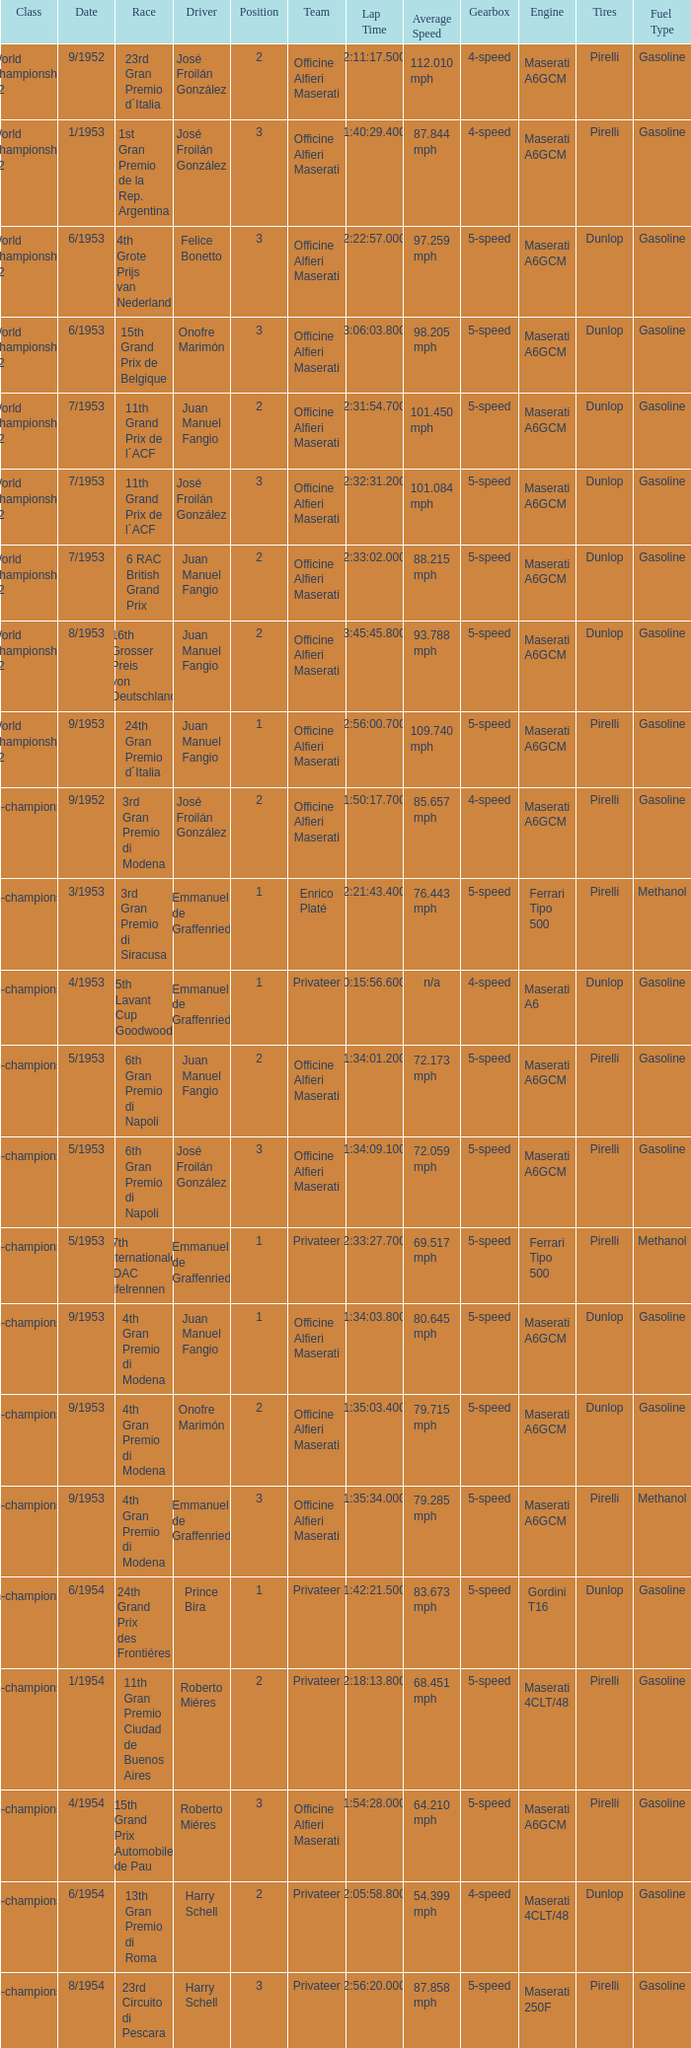Could you help me parse every detail presented in this table? {'header': ['Class', 'Date', 'Race', 'Driver', 'Position', 'Team', 'Lap Time', 'Average Speed', 'Gearbox', 'Engine', 'Tires', 'Fuel Type'], 'rows': [['World Championship F2', '9/1952', '23rd Gran Premio d´Italia', 'José Froilán González', '2', 'Officine Alfieri Maserati', '2:11:17.500', '112.010 mph', '4-speed', 'Maserati A6GCM', 'Pirelli', 'Gasoline'], ['World Championship F2', '1/1953', '1st Gran Premio de la Rep. Argentina', 'José Froilán González', '3', 'Officine Alfieri Maserati', '1:40:29.400', '87.844 mph', '4-speed', 'Maserati A6GCM', 'Pirelli', 'Gasoline'], ['World Championship F2', '6/1953', '4th Grote Prijs van Nederland', 'Felice Bonetto', '3', 'Officine Alfieri Maserati', '2:22:57.000', '97.259 mph', '5-speed', 'Maserati A6GCM', 'Dunlop', 'Gasoline'], ['World Championship F2', '6/1953', '15th Grand Prix de Belgique', 'Onofre Marimón', '3', 'Officine Alfieri Maserati', '3:06:03.800', '98.205 mph', '5-speed', 'Maserati A6GCM', 'Dunlop', 'Gasoline'], ['World Championship F2', '7/1953', '11th Grand Prix de l´ACF', 'Juan Manuel Fangio', '2', 'Officine Alfieri Maserati', '2:31:54.700', '101.450 mph', '5-speed', 'Maserati A6GCM', 'Dunlop', 'Gasoline'], ['World Championship F2', '7/1953', '11th Grand Prix de l´ACF', 'José Froilán González', '3', 'Officine Alfieri Maserati', '2:32:31.200', '101.084 mph', '5-speed', 'Maserati A6GCM', 'Dunlop', 'Gasoline'], ['World Championship F2', '7/1953', '6 RAC British Grand Prix', 'Juan Manuel Fangio', '2', 'Officine Alfieri Maserati', '2:33:02.000', '88.215 mph', '5-speed', 'Maserati A6GCM', 'Dunlop', 'Gasoline'], ['World Championship F2', '8/1953', '16th Grosser Preis von Deutschland', 'Juan Manuel Fangio', '2', 'Officine Alfieri Maserati', '3:45:45.800', '93.788 mph', '5-speed', 'Maserati A6GCM', 'Dunlop', 'Gasoline'], ['World Championship F2', '9/1953', '24th Gran Premio d´Italia', 'Juan Manuel Fangio', '1', 'Officine Alfieri Maserati', '2:56:00.700', '109.740 mph', '5-speed', 'Maserati A6GCM', 'Pirelli', 'Gasoline'], ['Non-championship F2', '9/1952', '3rd Gran Premio di Modena', 'José Froilán González', '2', 'Officine Alfieri Maserati', '1:50:17.700', '85.657 mph', '4-speed', 'Maserati A6GCM', 'Pirelli', 'Gasoline'], ['Non-championship F2', '3/1953', '3rd Gran Premio di Siracusa', 'Emmanuel de Graffenried', '1', 'Enrico Platé', '2:21:43.400', '76.443 mph', '5-speed', 'Ferrari Tipo 500', 'Pirelli', 'Methanol'], ['Non-championship F2', '4/1953', '5th Lavant Cup Goodwood', 'Emmanuel de Graffenried', '1', 'Privateer', '0:15:56.600', 'n/a', '4-speed', 'Maserati A6', 'Dunlop', 'Gasoline'], ['Non-championship F2', '5/1953', '6th Gran Premio di Napoli', 'Juan Manuel Fangio', '2', 'Officine Alfieri Maserati', '1:34:01.200', '72.173 mph', '5-speed', 'Maserati A6GCM', 'Pirelli', 'Gasoline'], ['Non-championship F2', '5/1953', '6th Gran Premio di Napoli', 'José Froilán González', '3', 'Officine Alfieri Maserati', '1:34:09.100', '72.059 mph', '5-speed', 'Maserati A6GCM', 'Pirelli', 'Gasoline'], ['Non-championship F2', '5/1953', '17th Internationales ADAC Eifelrennen', 'Emmanuel de Graffenried', '1', 'Privateer', '2:33:27.700', '69.517 mph', '5-speed', 'Ferrari Tipo 500', 'Pirelli', 'Methanol'], ['Non-championship F2', '9/1953', '4th Gran Premio di Modena', 'Juan Manuel Fangio', '1', 'Officine Alfieri Maserati', '1:34:03.800', '80.645 mph', '5-speed', 'Maserati A6GCM', 'Dunlop', 'Gasoline'], ['Non-championship F2', '9/1953', '4th Gran Premio di Modena', 'Onofre Marimón', '2', 'Officine Alfieri Maserati', '1:35:03.400', '79.715 mph', '5-speed', 'Maserati A6GCM', 'Dunlop', 'Gasoline'], ['Non-championship F2', '9/1953', '4th Gran Premio di Modena', 'Emmanuel de Graffenried', '3', 'Officine Alfieri Maserati', '1:35:34.000', '79.285 mph', '5-speed', 'Maserati A6GCM', 'Pirelli', 'Methanol'], ['(Non-championship) F2', '6/1954', '24th Grand Prix des Frontiéres', 'Prince Bira', '1', 'Privateer', '1:42:21.500', '83.673 mph', '5-speed', 'Gordini T16', 'Dunlop', 'Gasoline'], ['Non-championship F1', '1/1954', '11th Gran Premio Ciudad de Buenos Aires', 'Roberto Miéres', '2', 'Privateer', '2:18:13.800', '68.451 mph', '5-speed', 'Maserati 4CLT/48', 'Pirelli', 'Gasoline'], ['Non-championship F1', '4/1954', '15th Grand Prix Automobile de Pau', 'Roberto Miéres', '3', 'Officine Alfieri Maserati', '1:54:28.000', '64.210 mph', '5-speed', 'Maserati A6GCM', 'Pirelli', 'Gasoline'], ['Non-championship F1', '6/1954', '13th Gran Premio di Roma', 'Harry Schell', '2', 'Privateer', '2:05:58.800', '54.399 mph', '4-speed', 'Maserati 4CLT/48', 'Dunlop', 'Gasoline'], ['Non-championship F1', '8/1954', '23rd Circuito di Pescara', 'Harry Schell', '3', 'Privateer', '2:56:20.000', '87.858 mph', '5-speed', 'Maserati 250F', 'Pirelli', 'Gasoline']]} What class has the date of 8/1954? Non-championship F1. 